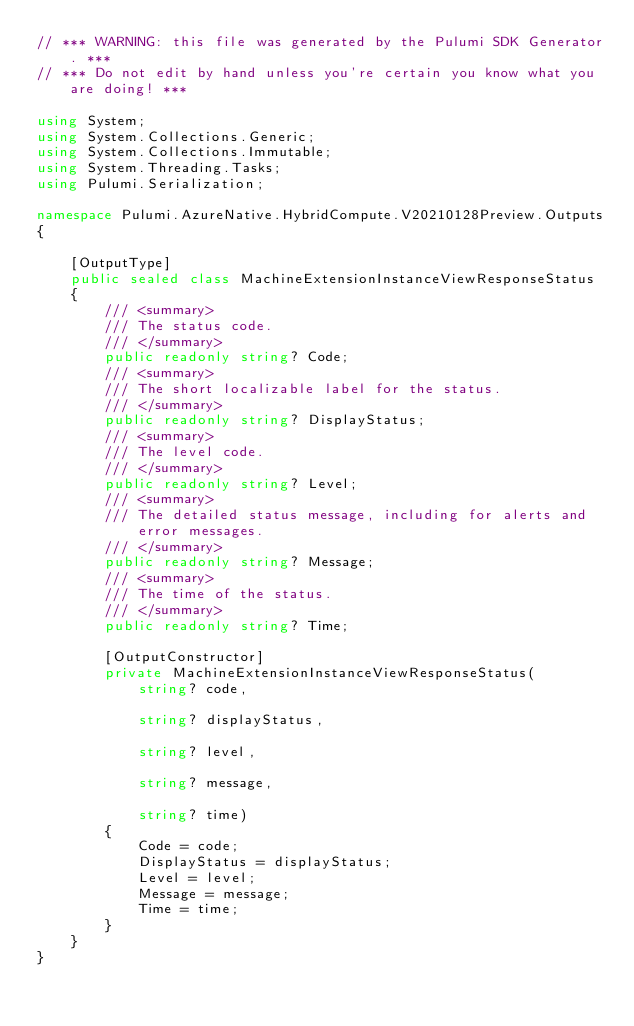<code> <loc_0><loc_0><loc_500><loc_500><_C#_>// *** WARNING: this file was generated by the Pulumi SDK Generator. ***
// *** Do not edit by hand unless you're certain you know what you are doing! ***

using System;
using System.Collections.Generic;
using System.Collections.Immutable;
using System.Threading.Tasks;
using Pulumi.Serialization;

namespace Pulumi.AzureNative.HybridCompute.V20210128Preview.Outputs
{

    [OutputType]
    public sealed class MachineExtensionInstanceViewResponseStatus
    {
        /// <summary>
        /// The status code.
        /// </summary>
        public readonly string? Code;
        /// <summary>
        /// The short localizable label for the status.
        /// </summary>
        public readonly string? DisplayStatus;
        /// <summary>
        /// The level code.
        /// </summary>
        public readonly string? Level;
        /// <summary>
        /// The detailed status message, including for alerts and error messages.
        /// </summary>
        public readonly string? Message;
        /// <summary>
        /// The time of the status.
        /// </summary>
        public readonly string? Time;

        [OutputConstructor]
        private MachineExtensionInstanceViewResponseStatus(
            string? code,

            string? displayStatus,

            string? level,

            string? message,

            string? time)
        {
            Code = code;
            DisplayStatus = displayStatus;
            Level = level;
            Message = message;
            Time = time;
        }
    }
}
</code> 